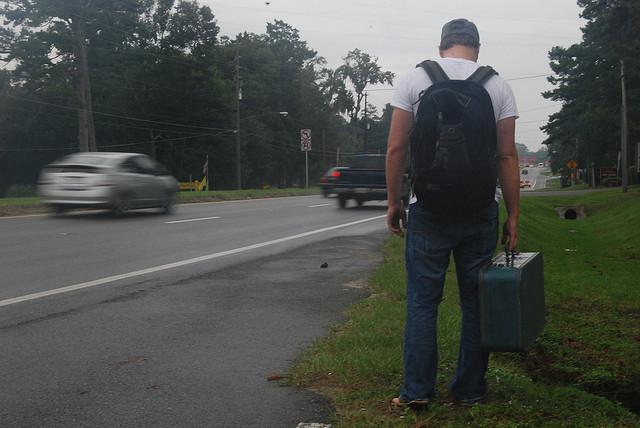How many cars are visible?
Give a very brief answer. 2. 